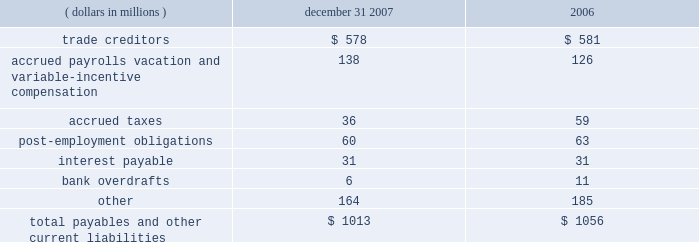Notes to the audited consolidated financial statements 6 .
Equity investments eastman has a 50 percent interest in and serves as the operating partner in primester , a joint venture which manufactures cellulose acetate at eastman's kingsport , tennessee plant .
This investment is accounted for under the equity method .
Eastman's net investment in the joint venture at december 31 , 2007 and 2006 was approximately $ 43 million and $ 47 million , respectively , which was comprised of the recognized portion of the venture's accumulated deficits , long-term amounts owed to primester , and a line of credit from eastman to primester .
Such amounts are included in other noncurrent assets .
Eastman owns a 50 percent interest in nanjing yangzi eastman chemical ltd .
( 201cnanjing 201d ) , a company which manufactures eastotactm hydrocarbon tackifying resins for the adhesives market .
This joint venture is accounted for under the equity method and is included in other noncurrent assets .
At december 31 , 2007 and 2006 , the company 2019s investment in nanjing was approximately $ 7 million and $ 5 million , respectively .
In october 2007 , the company entered into an agreement with green rock energy , l.l.c .
( "green rock" ) , a company formed by the d .
Shaw group and goldman , sachs & co. , to jointly develop the industrial gasification facility in beaumont , texas through tx energy , llc ( "tx energy" ) .
Eastman owns a 50 percent interest in tx energy , which is expected to be operational in 2011 and will produce intermediate chemicals , such as hydrogen , methanol , and ammonia from petroleum coke .
This joint venture in the development stage is accounted for under the equity method , and is included in other noncurrent assets .
At december 31 , 2007 , the company 2019s investment in tx energy was approximately $ 26 million .
Eastman also plans to participate in a project sponsored by faustina hydrogen products , l.l.c .
Which will use petroleum coke as the primary feedstock to make anhydrous ammonia and methanol .
Faustina hydrogen products is primarily owned by green rock .
The company intends to take a 25 percent or greater equity position in the project , provide operations , maintenance , and other site management services , and purchase methanol under a long-term contract .
Capital costs for the facility are estimated to be approximately $ 1.6 billion .
Project financing is expected to be obtained by the end of 2008 .
The facility will be built in st .
James parish , louisiana and is expected to be complete by 2011 .
On april 21 , 2005 , the company completed the sale of its equity investment in genencor international , inc .
( "genencor" ) for cash proceeds of approximately $ 417 million , net of $ 2 million in fees .
The book value of the investment prior to sale was $ 246 million , and the company recorded a pre-tax gain on the sale of $ 171 million .
Payables and other current liabilities december 31 , ( dollars in millions ) 2007 2006 .
The current portion of post-employment obligations is an estimate of current year payments in excess of plan assets. .
What was the percent of the trade to the creditors to the total payable and other current liabilities? 
Computations: (578 / 1013)
Answer: 0.57058. 